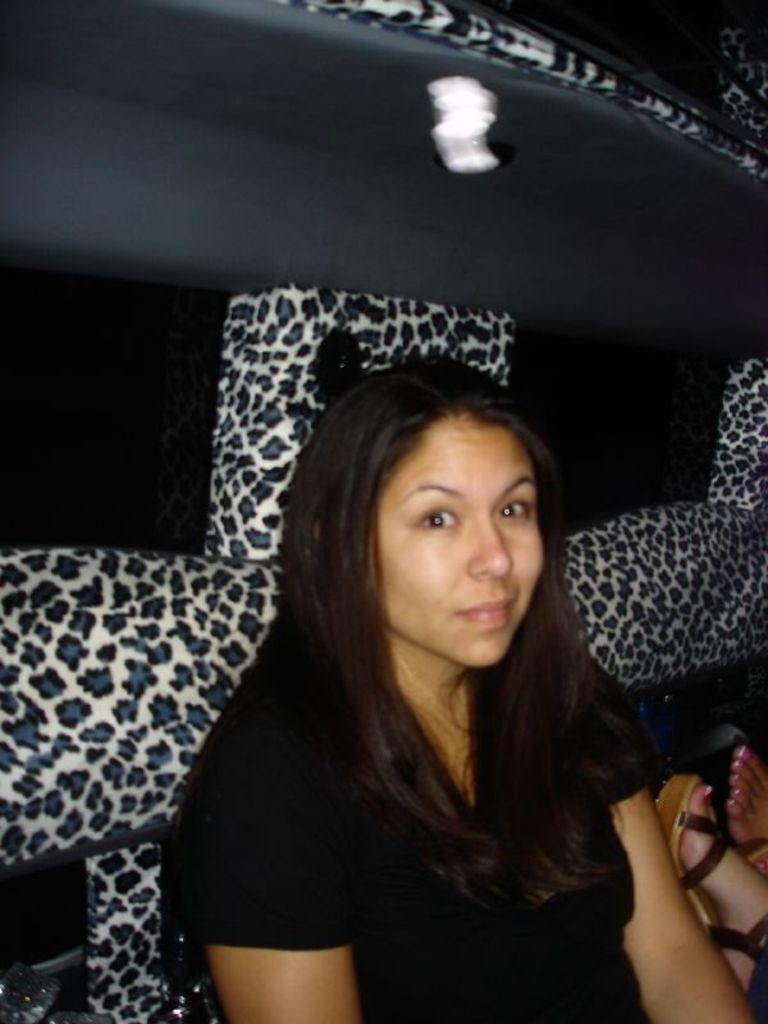Who is present in the image? There is a woman in the image. What is the woman wearing? The woman is wearing a black dress. What can be seen in the background of the image? There is a black and white object in the background of the image. Can you describe the legs visible on the right side of the image? The legs visible on the right side of the image belong to a person. What type of ring can be seen on the woman's finger in the image? There is no ring visible on the woman's finger in the image. Can you describe the field in the background of the image? There is no field present in the image; it features a black and white object in the background. 